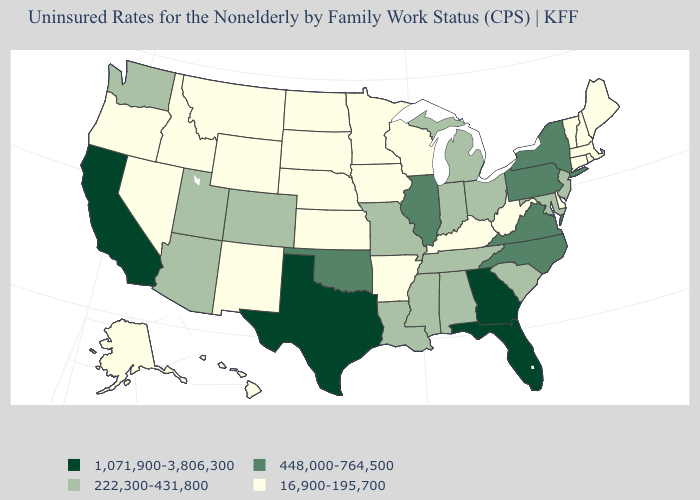What is the value of Connecticut?
Be succinct. 16,900-195,700. What is the value of Michigan?
Answer briefly. 222,300-431,800. What is the value of Oklahoma?
Quick response, please. 448,000-764,500. Does the first symbol in the legend represent the smallest category?
Short answer required. No. What is the value of South Dakota?
Give a very brief answer. 16,900-195,700. What is the value of Missouri?
Give a very brief answer. 222,300-431,800. Which states have the lowest value in the MidWest?
Answer briefly. Iowa, Kansas, Minnesota, Nebraska, North Dakota, South Dakota, Wisconsin. Which states hav the highest value in the South?
Give a very brief answer. Florida, Georgia, Texas. What is the value of South Dakota?
Keep it brief. 16,900-195,700. What is the value of Virginia?
Give a very brief answer. 448,000-764,500. Name the states that have a value in the range 222,300-431,800?
Be succinct. Alabama, Arizona, Colorado, Indiana, Louisiana, Maryland, Michigan, Mississippi, Missouri, New Jersey, Ohio, South Carolina, Tennessee, Utah, Washington. What is the highest value in the MidWest ?
Give a very brief answer. 448,000-764,500. Does Colorado have a lower value than Wyoming?
Short answer required. No. 